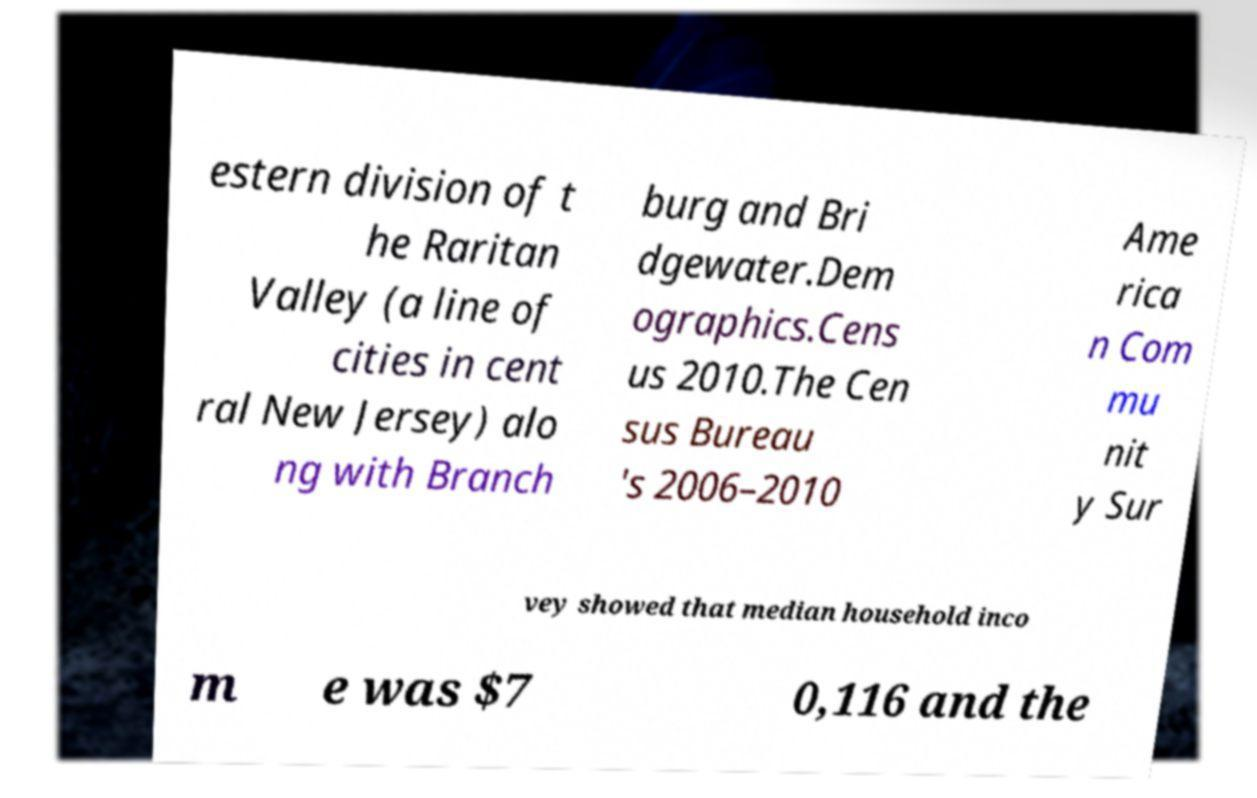For documentation purposes, I need the text within this image transcribed. Could you provide that? estern division of t he Raritan Valley (a line of cities in cent ral New Jersey) alo ng with Branch burg and Bri dgewater.Dem ographics.Cens us 2010.The Cen sus Bureau 's 2006–2010 Ame rica n Com mu nit y Sur vey showed that median household inco m e was $7 0,116 and the 